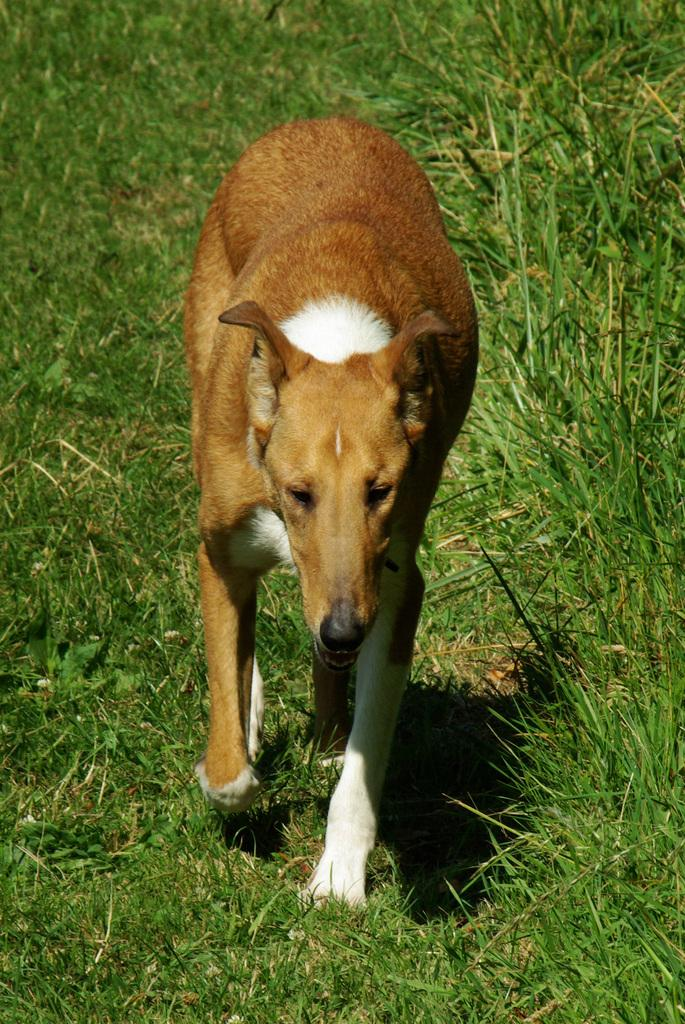What is the main subject of the image? The main subject of the image is a dog. Where is the dog located in the image? The dog is on the grass. How does the dog change its appearance in the image? The dog does not change its appearance in the image; it remains the same throughout. Can you tell me how many times the dog folds its ears in the image? The dog does not fold its ears in the image; it is simply standing on the grass. 